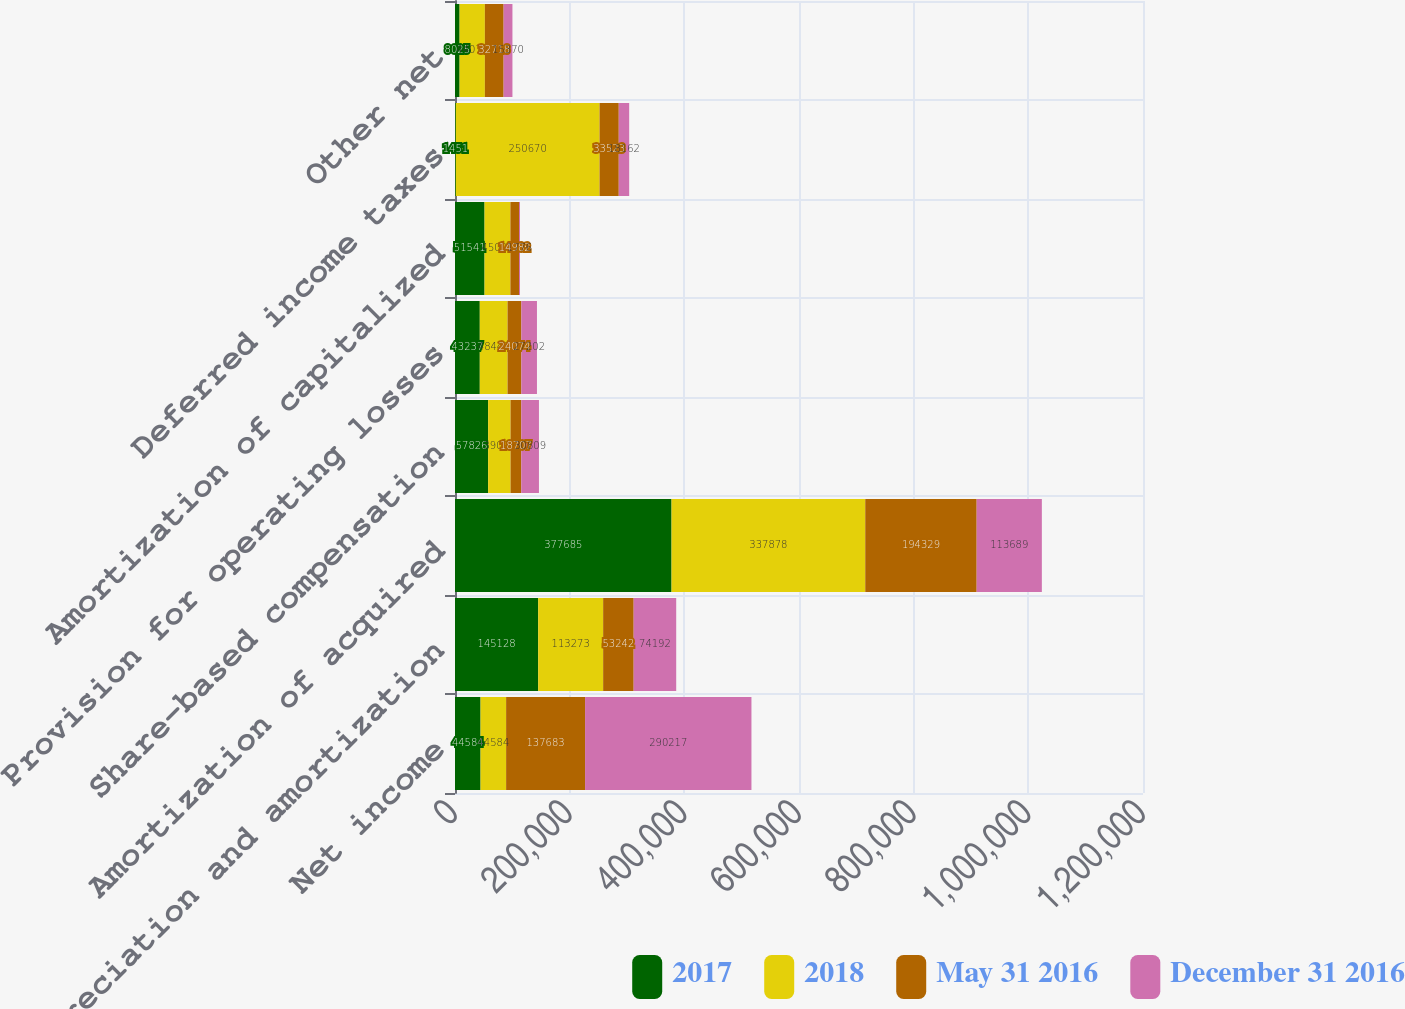<chart> <loc_0><loc_0><loc_500><loc_500><stacked_bar_chart><ecel><fcel>Net income<fcel>Depreciation and amortization<fcel>Amortization of acquired<fcel>Share-based compensation<fcel>Provision for operating losses<fcel>Amortization of capitalized<fcel>Deferred income taxes<fcel>Other net<nl><fcel>2017<fcel>44584<fcel>145128<fcel>377685<fcel>57826<fcel>43237<fcel>51541<fcel>1451<fcel>8025<nl><fcel>2018<fcel>44584<fcel>113273<fcel>337878<fcel>39095<fcel>48443<fcel>45098<fcel>250670<fcel>44070<nl><fcel>May 31 2016<fcel>137683<fcel>53242<fcel>194329<fcel>18707<fcel>24074<fcel>14982<fcel>33523<fcel>32718<nl><fcel>December 31 2016<fcel>290217<fcel>74192<fcel>113689<fcel>30809<fcel>27202<fcel>1776<fcel>18162<fcel>15370<nl></chart> 